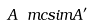<formula> <loc_0><loc_0><loc_500><loc_500>A \ m c s i m A ^ { \prime }</formula> 